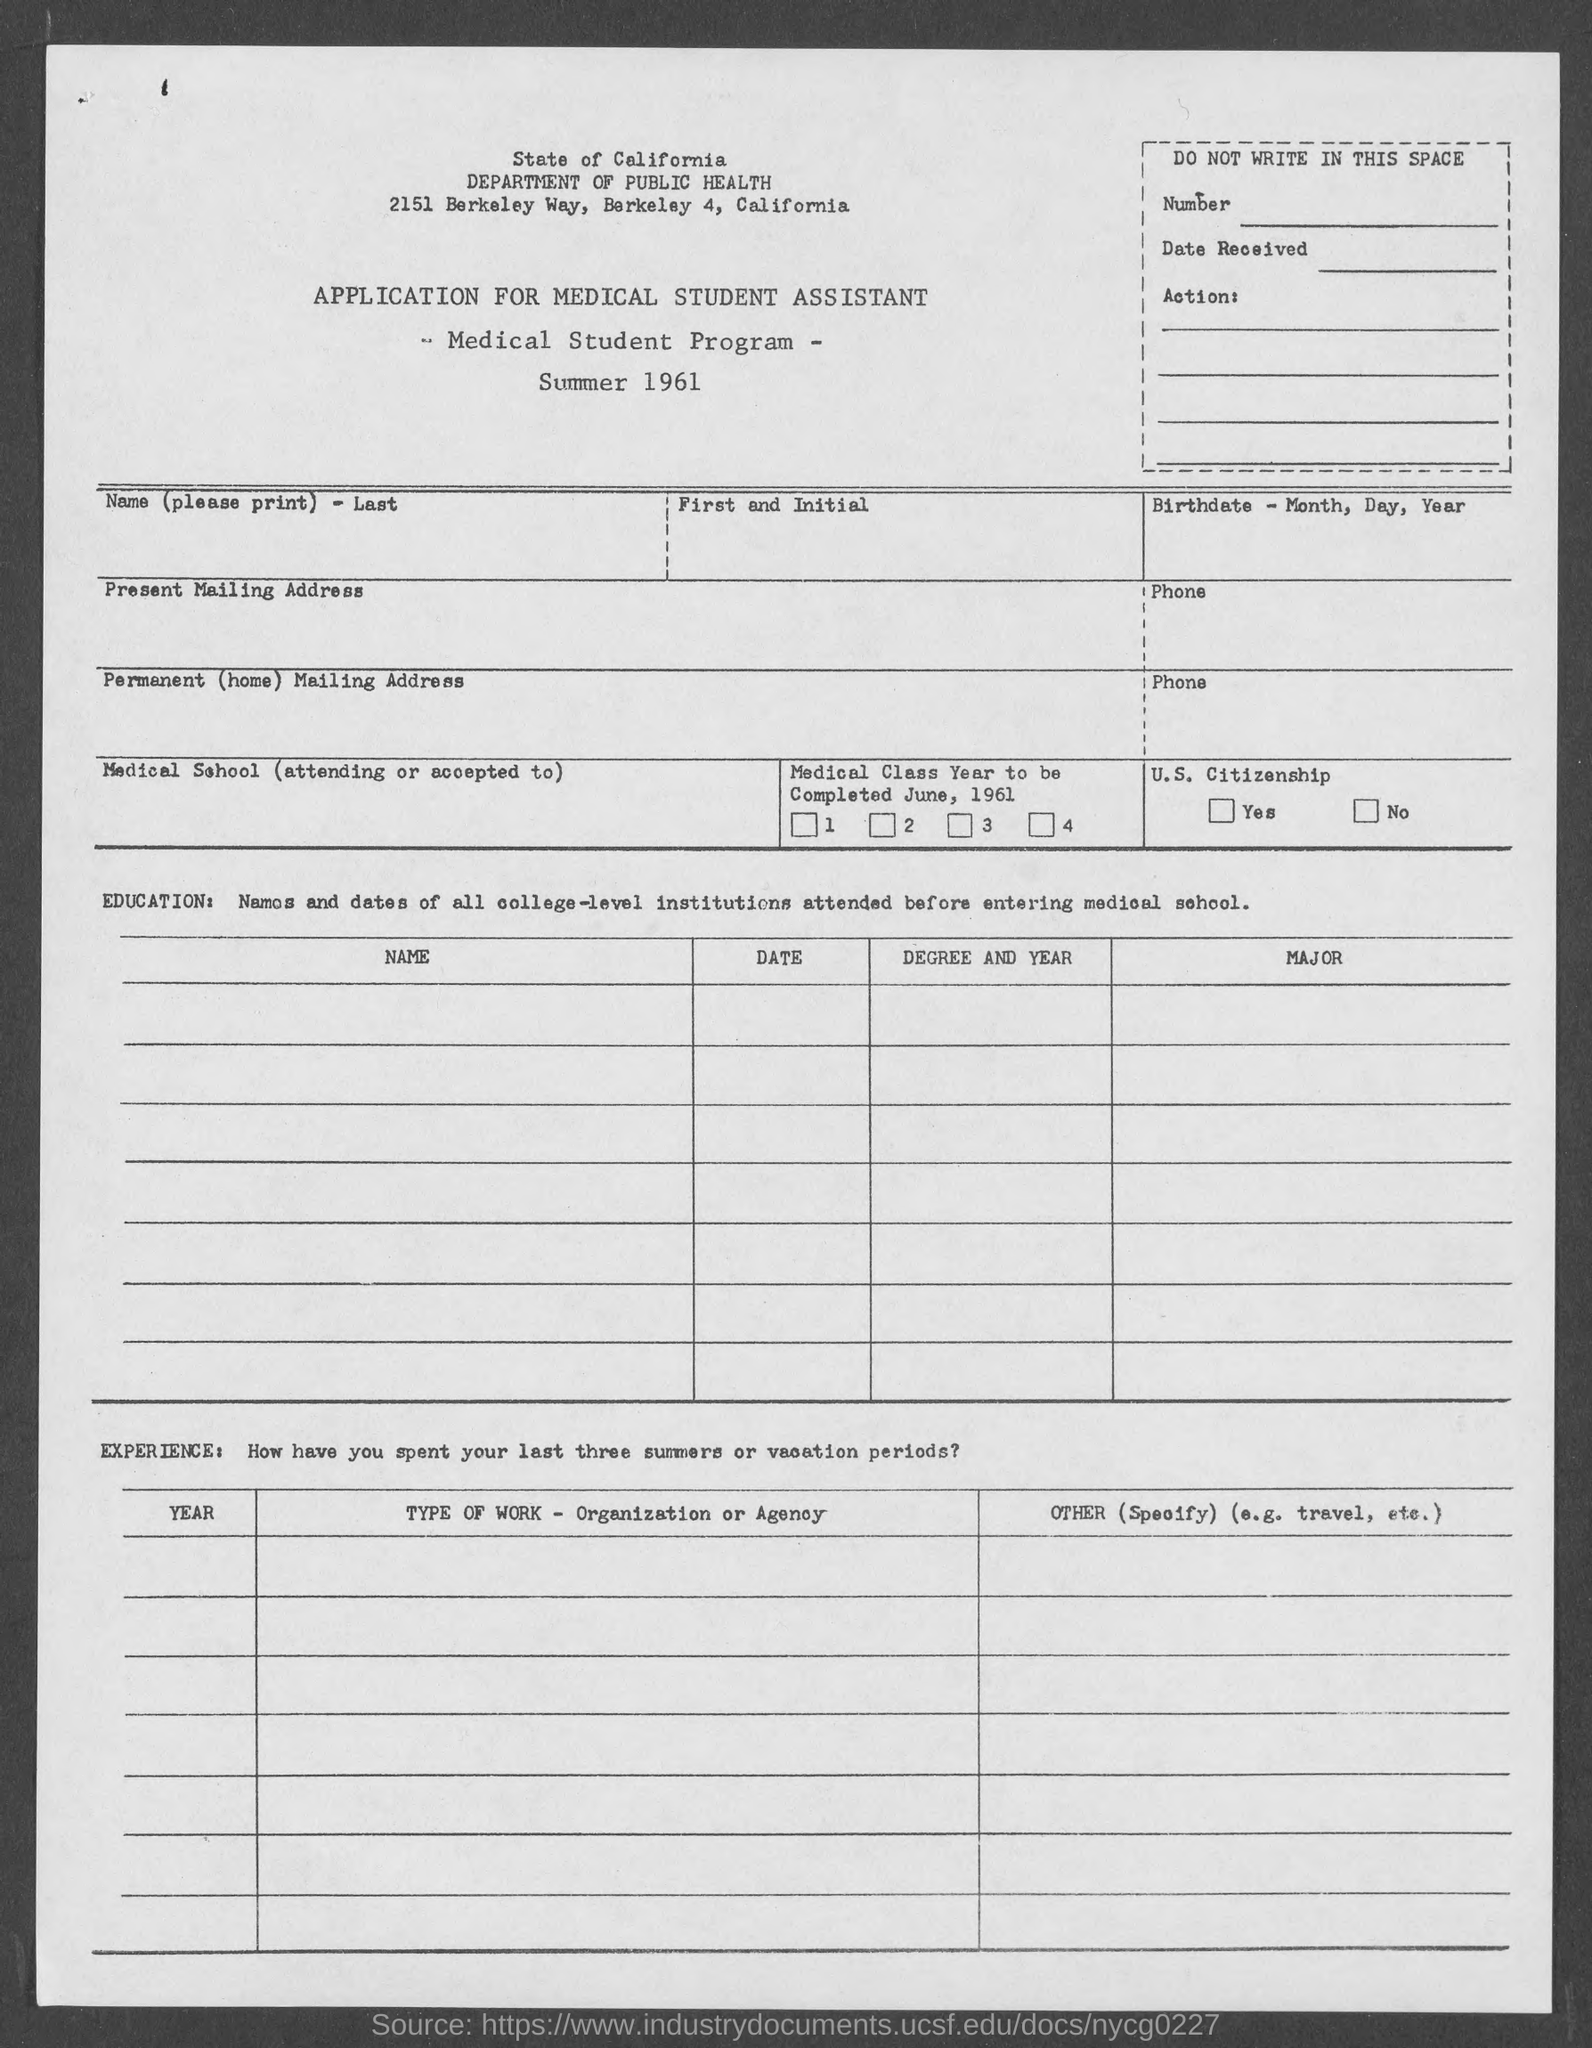List a handful of essential elements in this visual. The Department of Public Health is the department that was mentioned. 